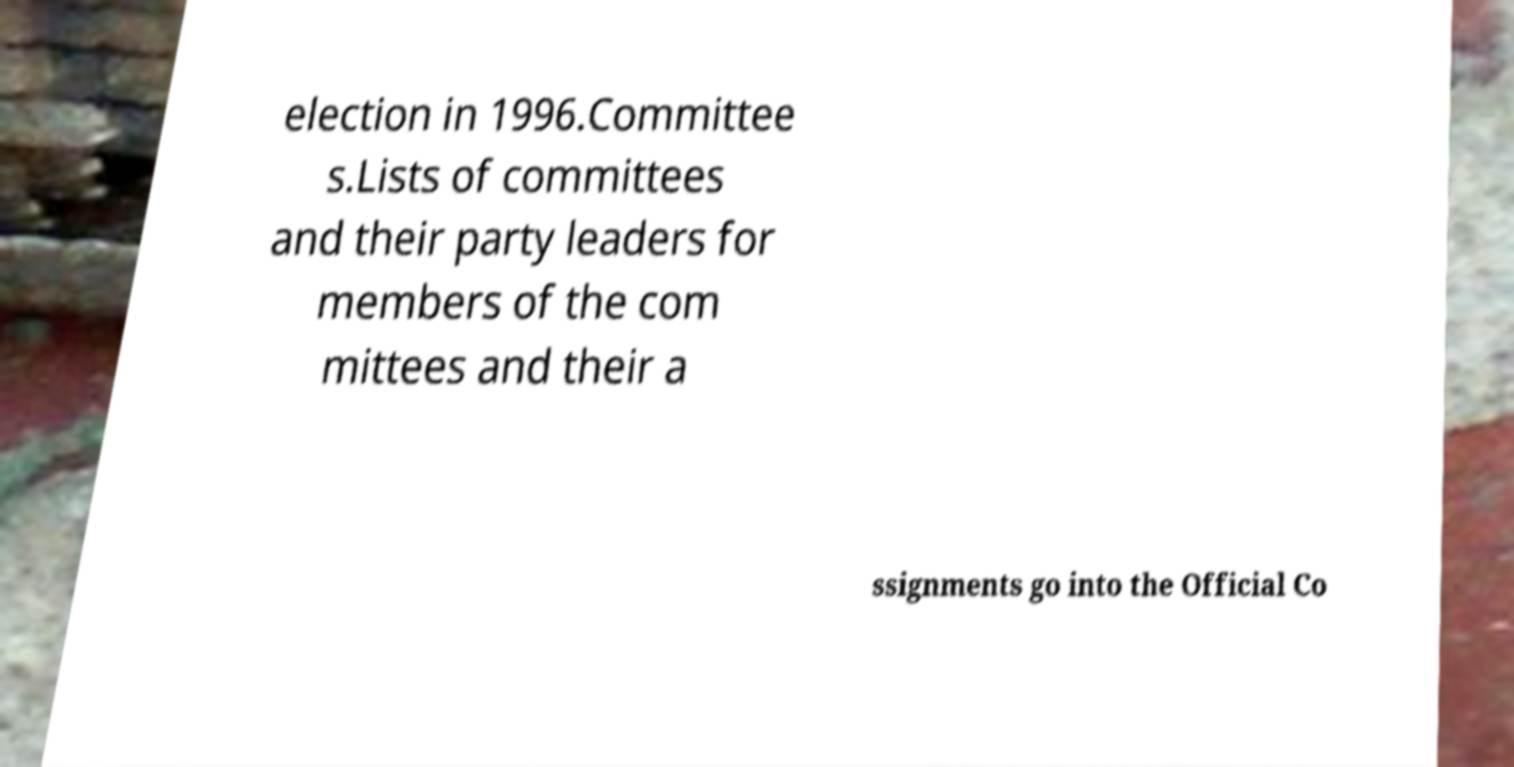Could you extract and type out the text from this image? election in 1996.Committee s.Lists of committees and their party leaders for members of the com mittees and their a ssignments go into the Official Co 